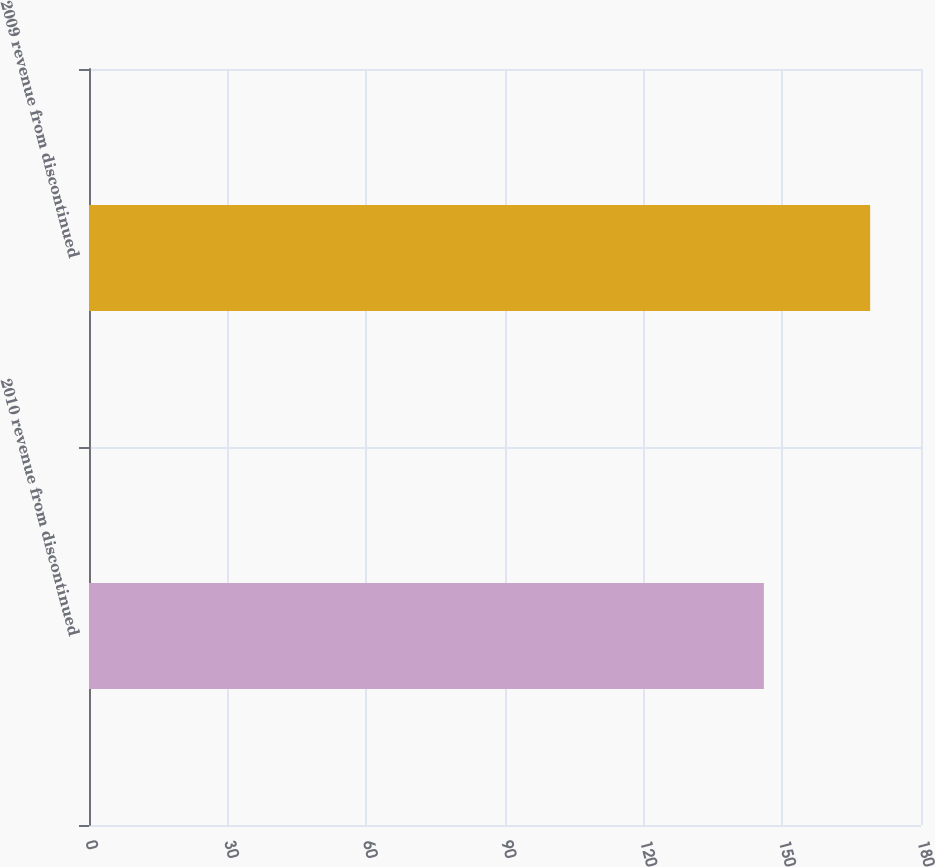Convert chart to OTSL. <chart><loc_0><loc_0><loc_500><loc_500><bar_chart><fcel>2010 revenue from discontinued<fcel>2009 revenue from discontinued<nl><fcel>146<fcel>169<nl></chart> 